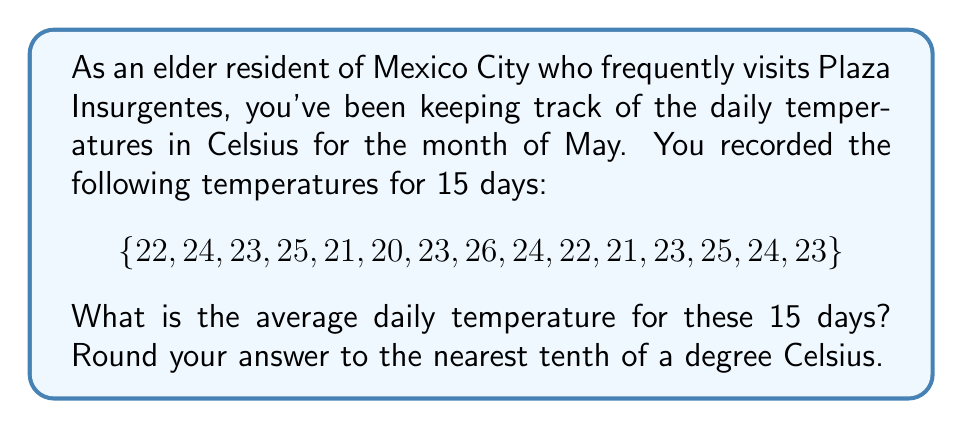Help me with this question. To find the average daily temperature, we need to follow these steps:

1. Add up all the temperatures:
   $$22 + 24 + 23 + 25 + 21 + 20 + 23 + 26 + 24 + 22 + 21 + 23 + 25 + 24 + 23 = 346°C$$

2. Count the total number of days:
   There are 15 days in our data set.

3. Divide the sum of temperatures by the number of days:
   $$\text{Average} = \frac{\text{Sum of temperatures}}{\text{Number of days}} = \frac{346}{15} = 23.0666...°C$$

4. Round the result to the nearest tenth:
   $23.0666...$ rounds to $23.1°C$
Answer: $23.1°C$ 